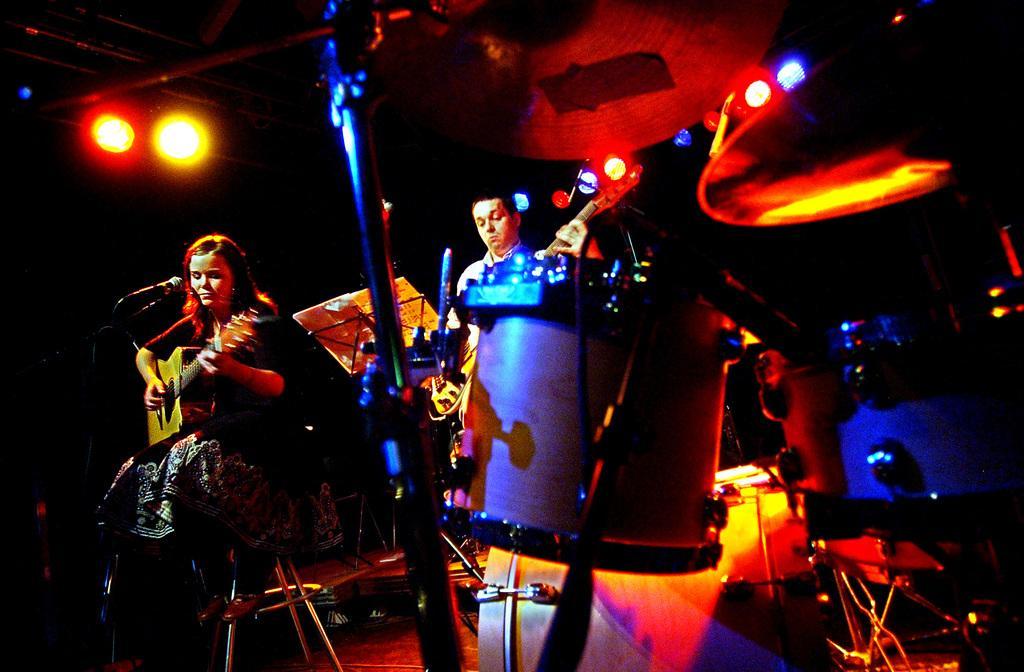Could you give a brief overview of what you see in this image? This image is taken in a concert. In the left side of the image there is a woman sitting on a chair holding a guitar in her hand. In the middle of the image there are few musical instruments and a man standing on the dais. At the top of the image there are few lights. 